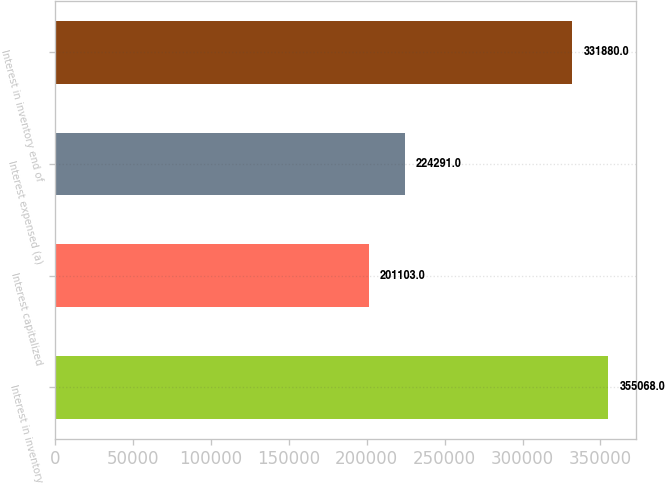Convert chart. <chart><loc_0><loc_0><loc_500><loc_500><bar_chart><fcel>Interest in inventory<fcel>Interest capitalized<fcel>Interest expensed (a)<fcel>Interest in inventory end of<nl><fcel>355068<fcel>201103<fcel>224291<fcel>331880<nl></chart> 